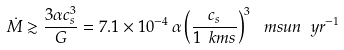Convert formula to latex. <formula><loc_0><loc_0><loc_500><loc_500>\dot { M } \gtrsim \frac { 3 \alpha c _ { s } ^ { 3 } } { G } = 7 . 1 \times 1 0 ^ { - 4 } \, \alpha \left ( \frac { c _ { s } } { 1 \ k m s } \right ) ^ { 3 } \, \ m s u n \ y r ^ { - 1 }</formula> 